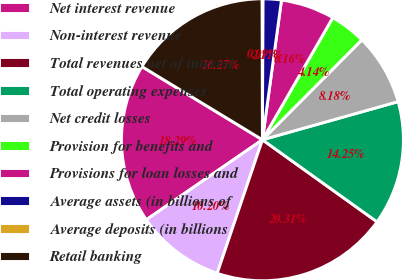Convert chart to OTSL. <chart><loc_0><loc_0><loc_500><loc_500><pie_chart><fcel>Net interest revenue<fcel>Non-interest revenue<fcel>Total revenues net of interest<fcel>Total operating expenses<fcel>Net credit losses<fcel>Provision for benefits and<fcel>Provisions for loan losses and<fcel>Average assets (in billions of<fcel>Average deposits (in billions<fcel>Retail banking<nl><fcel>18.29%<fcel>10.2%<fcel>20.31%<fcel>14.25%<fcel>8.18%<fcel>4.14%<fcel>6.16%<fcel>2.11%<fcel>0.09%<fcel>16.27%<nl></chart> 